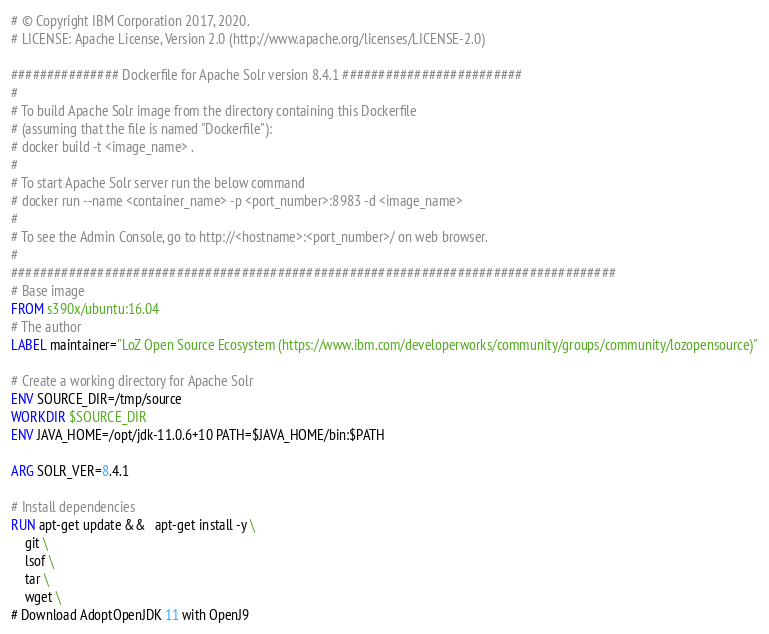<code> <loc_0><loc_0><loc_500><loc_500><_Dockerfile_># © Copyright IBM Corporation 2017, 2020.
# LICENSE: Apache License, Version 2.0 (http://www.apache.org/licenses/LICENSE-2.0)

############### Dockerfile for Apache Solr version 8.4.1 #########################
#
# To build Apache Solr image from the directory containing this Dockerfile
# (assuming that the file is named "Dockerfile"):
# docker build -t <image_name> .
#
# To start Apache Solr server run the below command
# docker run --name <container_name> -p <port_number>:8983 -d <image_name>
#
# To see the Admin Console, go to http://<hostname>:<port_number>/ on web browser.
#
####################################################################################
# Base image
FROM s390x/ubuntu:16.04
# The author
LABEL maintainer="LoZ Open Source Ecosystem (https://www.ibm.com/developerworks/community/groups/community/lozopensource)"

# Create a working directory for Apache Solr
ENV SOURCE_DIR=/tmp/source
WORKDIR $SOURCE_DIR
ENV JAVA_HOME=/opt/jdk-11.0.6+10 PATH=$JAVA_HOME/bin:$PATH

ARG SOLR_VER=8.4.1

# Install dependencies
RUN apt-get update &&   apt-get install -y \
    git \
    lsof \
    tar \
    wget \
# Download AdoptOpenJDK 11 with OpenJ9</code> 